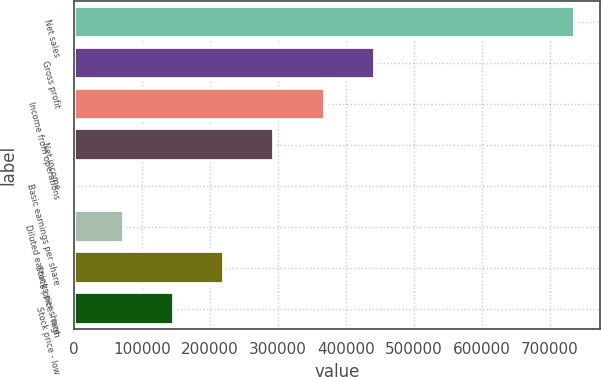Convert chart to OTSL. <chart><loc_0><loc_0><loc_500><loc_500><bar_chart><fcel>Net sales<fcel>Gross profit<fcel>Income from operations<fcel>Net income<fcel>Basic earnings per share<fcel>Diluted earnings per share<fcel>Stock price - high<fcel>Stock price - low<nl><fcel>736579<fcel>441948<fcel>368290<fcel>294632<fcel>0.63<fcel>73658.5<fcel>220974<fcel>147316<nl></chart> 